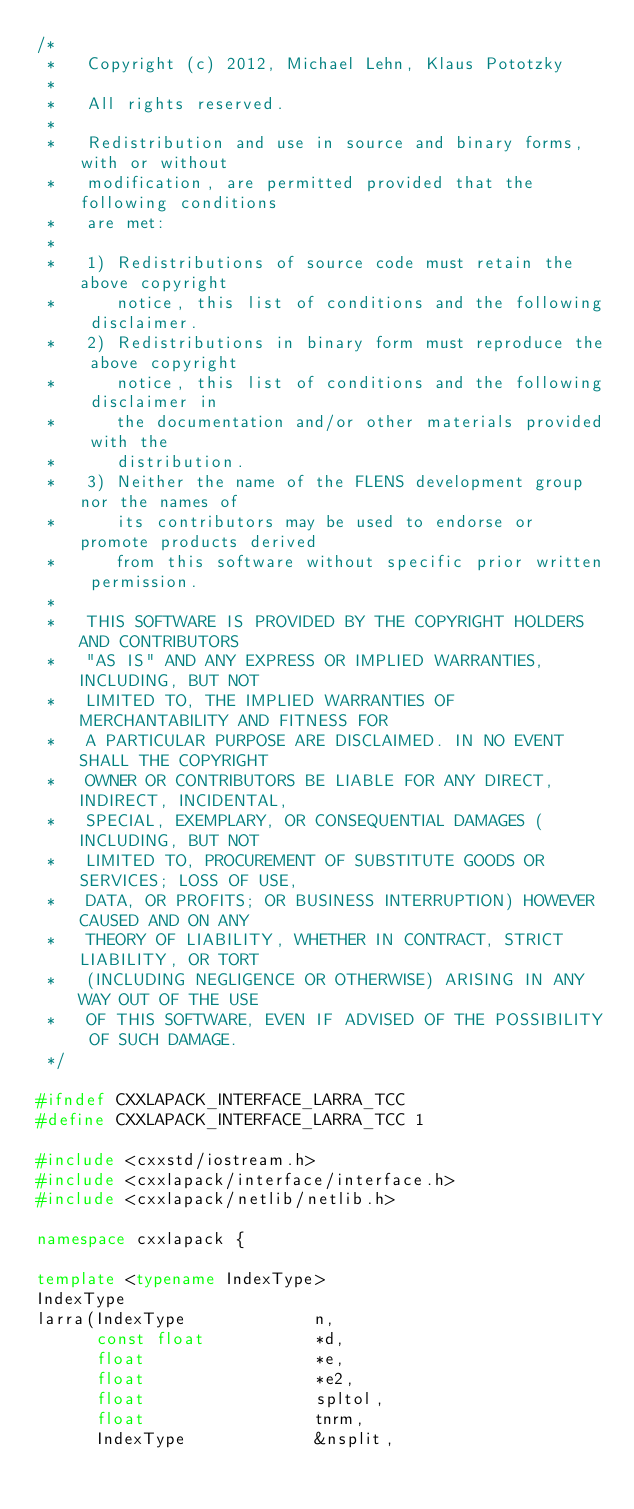<code> <loc_0><loc_0><loc_500><loc_500><_C++_>/*
 *   Copyright (c) 2012, Michael Lehn, Klaus Pototzky
 *
 *   All rights reserved.
 *
 *   Redistribution and use in source and binary forms, with or without
 *   modification, are permitted provided that the following conditions
 *   are met:
 *
 *   1) Redistributions of source code must retain the above copyright
 *      notice, this list of conditions and the following disclaimer.
 *   2) Redistributions in binary form must reproduce the above copyright
 *      notice, this list of conditions and the following disclaimer in
 *      the documentation and/or other materials provided with the
 *      distribution.
 *   3) Neither the name of the FLENS development group nor the names of
 *      its contributors may be used to endorse or promote products derived
 *      from this software without specific prior written permission.
 *
 *   THIS SOFTWARE IS PROVIDED BY THE COPYRIGHT HOLDERS AND CONTRIBUTORS
 *   "AS IS" AND ANY EXPRESS OR IMPLIED WARRANTIES, INCLUDING, BUT NOT
 *   LIMITED TO, THE IMPLIED WARRANTIES OF MERCHANTABILITY AND FITNESS FOR
 *   A PARTICULAR PURPOSE ARE DISCLAIMED. IN NO EVENT SHALL THE COPYRIGHT
 *   OWNER OR CONTRIBUTORS BE LIABLE FOR ANY DIRECT, INDIRECT, INCIDENTAL,
 *   SPECIAL, EXEMPLARY, OR CONSEQUENTIAL DAMAGES (INCLUDING, BUT NOT
 *   LIMITED TO, PROCUREMENT OF SUBSTITUTE GOODS OR SERVICES; LOSS OF USE,
 *   DATA, OR PROFITS; OR BUSINESS INTERRUPTION) HOWEVER CAUSED AND ON ANY
 *   THEORY OF LIABILITY, WHETHER IN CONTRACT, STRICT LIABILITY, OR TORT
 *   (INCLUDING NEGLIGENCE OR OTHERWISE) ARISING IN ANY WAY OUT OF THE USE
 *   OF THIS SOFTWARE, EVEN IF ADVISED OF THE POSSIBILITY OF SUCH DAMAGE.
 */

#ifndef CXXLAPACK_INTERFACE_LARRA_TCC
#define CXXLAPACK_INTERFACE_LARRA_TCC 1

#include <cxxstd/iostream.h>
#include <cxxlapack/interface/interface.h>
#include <cxxlapack/netlib/netlib.h>

namespace cxxlapack {

template <typename IndexType>
IndexType
larra(IndexType             n,
      const float           *d,
      float                 *e,
      float                 *e2,
      float                 spltol,
      float                 tnrm,
      IndexType             &nsplit,</code> 